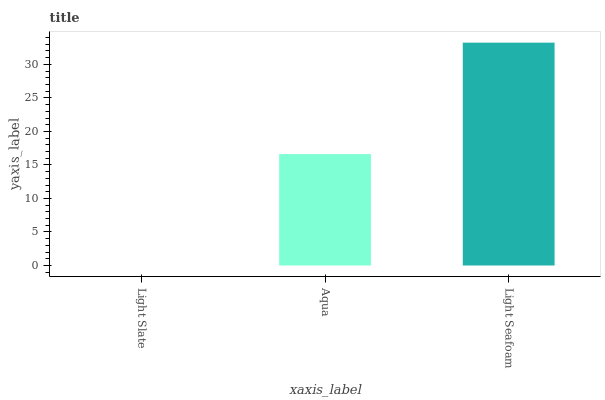Is Light Slate the minimum?
Answer yes or no. Yes. Is Light Seafoam the maximum?
Answer yes or no. Yes. Is Aqua the minimum?
Answer yes or no. No. Is Aqua the maximum?
Answer yes or no. No. Is Aqua greater than Light Slate?
Answer yes or no. Yes. Is Light Slate less than Aqua?
Answer yes or no. Yes. Is Light Slate greater than Aqua?
Answer yes or no. No. Is Aqua less than Light Slate?
Answer yes or no. No. Is Aqua the high median?
Answer yes or no. Yes. Is Aqua the low median?
Answer yes or no. Yes. Is Light Slate the high median?
Answer yes or no. No. Is Light Seafoam the low median?
Answer yes or no. No. 